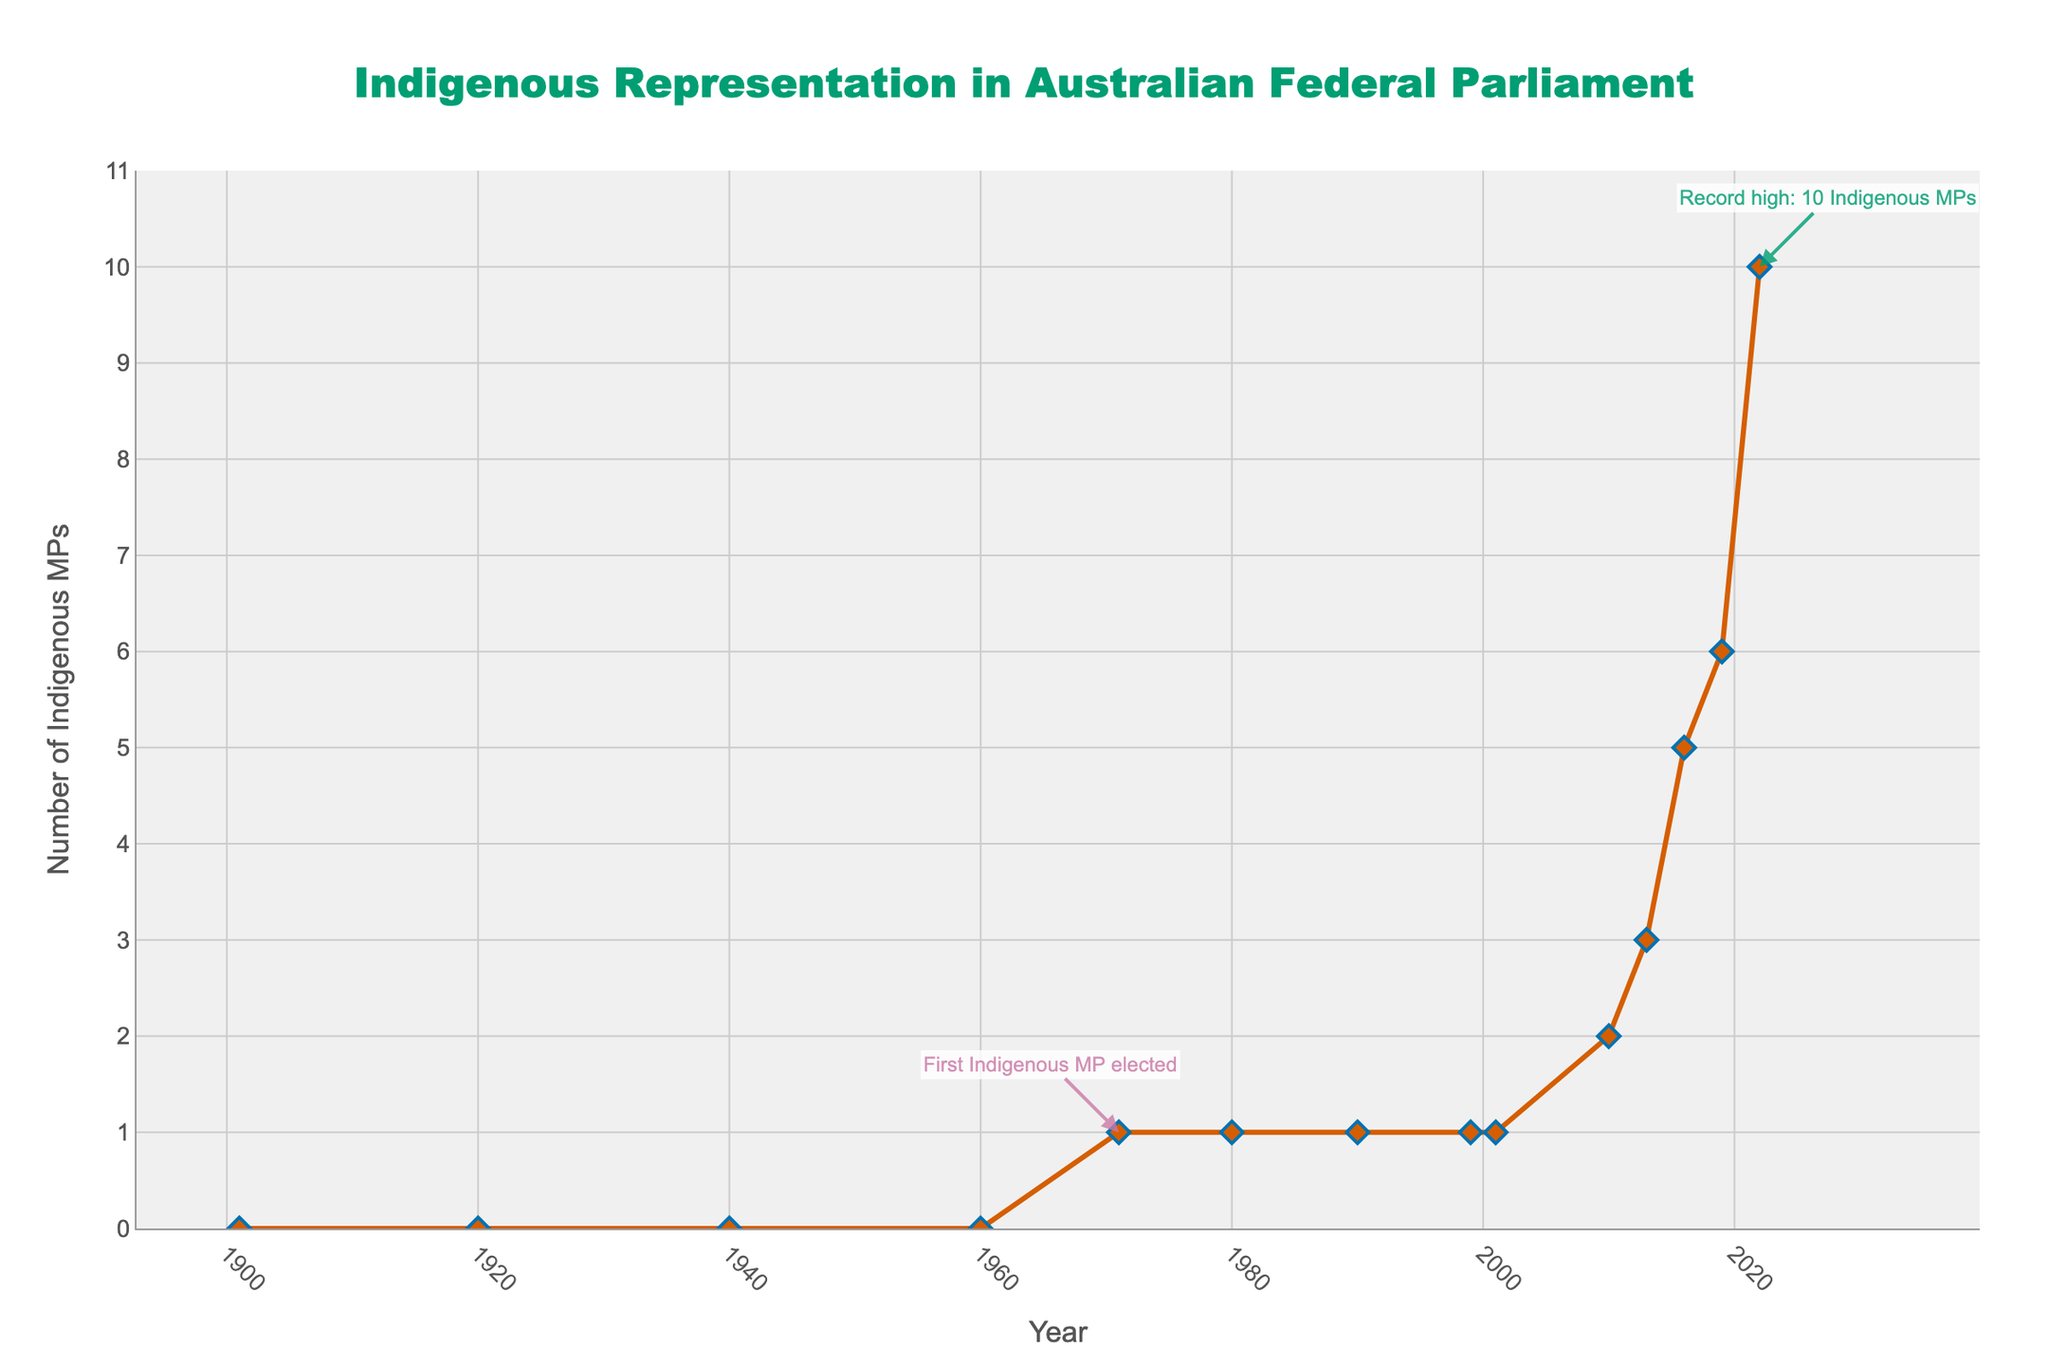What is the highest number of Indigenous MPs recorded in any given year? From the figure, the highest number recorded is 10 Indigenous MPs in the year 2022. This is also highlighted with an annotation on the chart.
Answer: 10 In which year was the first Indigenous MP elected to the Australian parliament? The figure has an annotation pointing to the year 1971, indicating that the first Indigenous MP was elected that year.
Answer: 1971 How many Indigenous MPs were there in the year 1990? From the figure, the data point at the year 1990 shows that there was 1 Indigenous MP in the Australian parliament.
Answer: 1 Compare the number of Indigenous MPs in 2016 and 2022. How many more Indigenous MPs were there in 2022 compared to 2016? In 2016, there were 5 Indigenous MPs, and in 2022, there were 10. Therefore, there were 10 - 5 = 5 more Indigenous MPs in 2022 compared to 2016.
Answer: 5 Describe the trend in Indigenous representation in the Australian parliament from 1901 to 2022. The trend from 1901 to 2022 shows that there were no Indigenous MPs until 1971, when the first Indigenous MP was elected. The number remained low (1) until after 1999. From 2010 onwards, there is a noticeable increase, reaching a peak of 10 Indigenous MPs in 2022.
Answer: Increasing trend, especially after 2010 What was the number of Indigenous MPs in 2013, and how does it compare to the number in 2019? In 2013, there were 3 Indigenous MPs, and in 2019, there were 6. Therefore, there were 6 - 3 = 3 more Indigenous MPs in 2019 than in 2013.
Answer: 3 more in 2019 Between which years did the number of Indigenous MPs remain constant at 1? The figure shows that from 1971 to 2010, the number of Indigenous MPs remained constant at 1.
Answer: From 1971 to 2010 What is the average number of Indigenous MPs from 2001 to 2022? The numbers from 2001 to 2022 are 1, 2, 3, 5, 6, 10. Summing these gives 27. There are 6 data points. Therefore, the average is 27 / 6 = 4.5
Answer: 4.5 How many years did it take from the first Indigenous MP being elected until the number of Indigenous MPs reached 5? The first Indigenous MP was elected in 1971, and the number reached 5 in 2016. Therefore, it took 2016 - 1971 = 45 years.
Answer: 45 years 